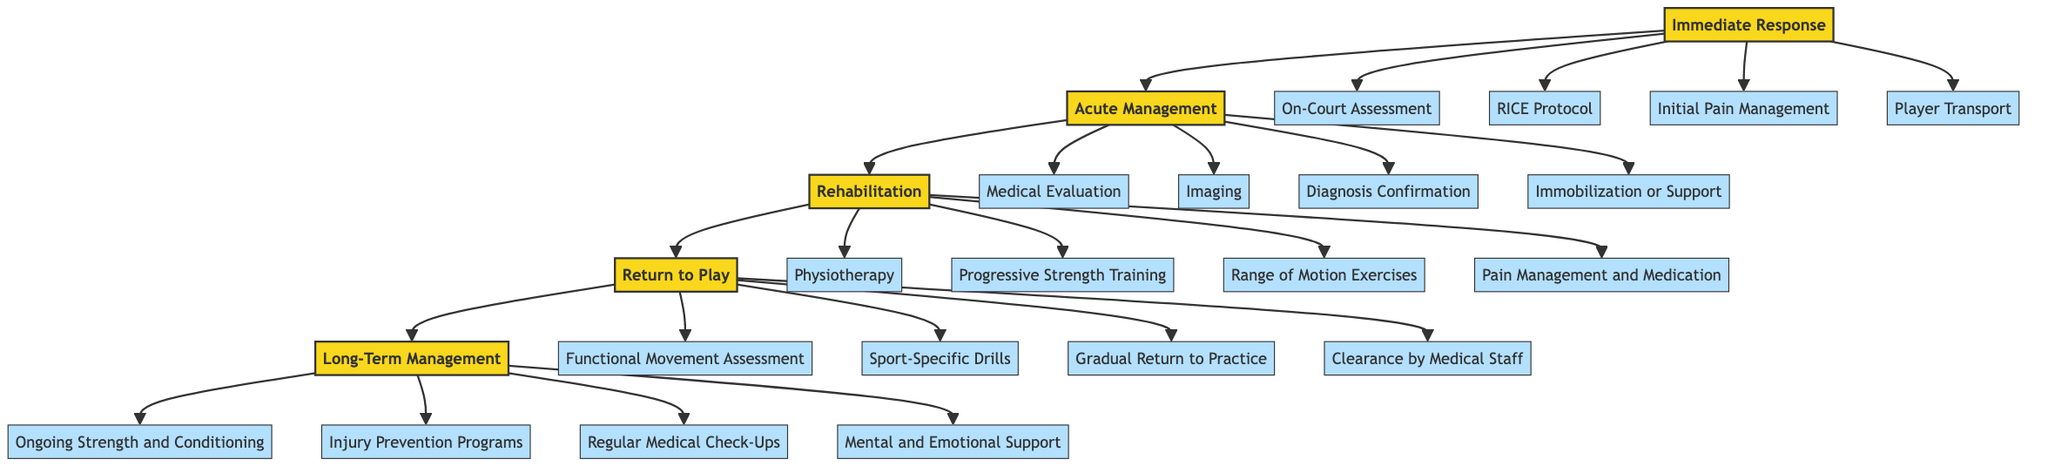What is the first stage of the basketball injury management pathway? The diagram shows that the first stage in the pathway is labeled 'Immediate Response.'
Answer: Immediate Response How many interventions are listed under the Acute Management stage? Under the Acute Management stage, there are four interventions detailed (Medical Evaluation, Imaging, Diagnosis Confirmation, Immobilization or Support).
Answer: 4 What intervention is associated with the Return to Play stage that involves ensuring a player is physically ready? The intervention that ensures a player is physically ready in the Return to Play stage is 'Functional Movement Assessment.'
Answer: Functional Movement Assessment Which intervention in the Long-Term Management stage focuses on player well-being? In the Long-Term Management stage, 'Mental and Emotional Support' is the intervention that centers around player well-being.
Answer: Mental and Emotional Support What comes after the Rehabilitation stage? Following the Rehabilitation stage in the path, the next stage is 'Return to Play.'
Answer: Return to Play How many total stages are presented in the basketball injury management pathway? The diagram outlines five distinct stages (Immediate Response, Acute Management, Rehabilitation, Return to Play, Long-Term Management).
Answer: 5 What is the last intervention listed in the Long-Term Management stage? The last intervention in the Long-Term Management stage, as per the diagram, is 'Mental and Emotional Support.'
Answer: Mental and Emotional Support Which stage includes the RICE protocol as an intervention? The intervention of the RICE protocol is included in the first stage, which is 'Immediate Response.'
Answer: Immediate Response 